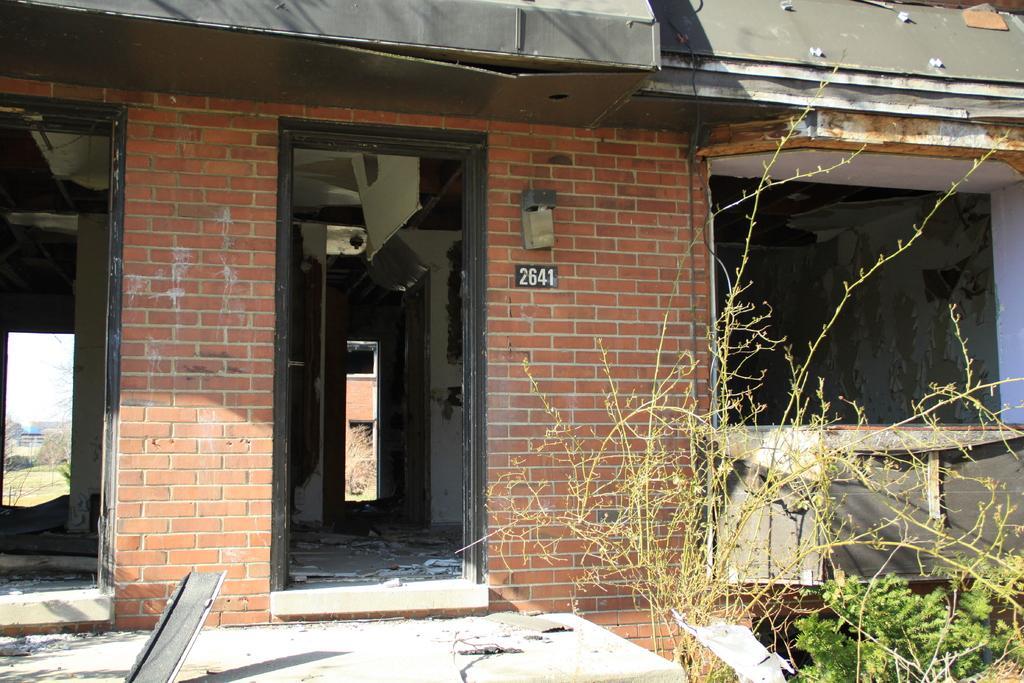Can you describe this image briefly? There is a building with brick wall. There is a number on the wall. On the right side there are plants. 